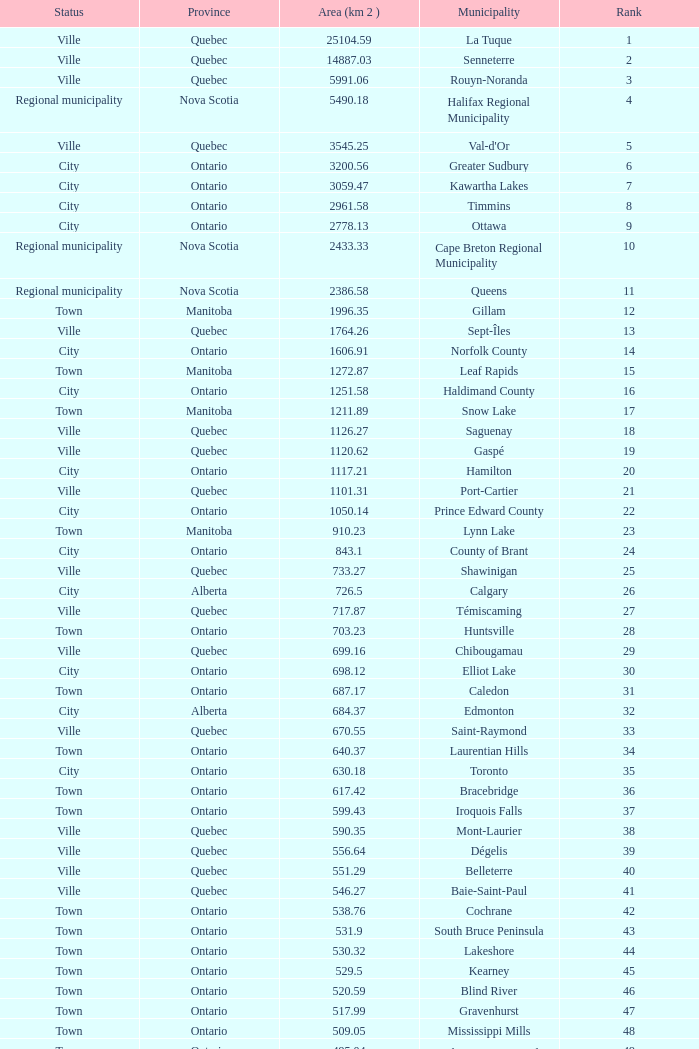What's the total of Rank that has an Area (KM 2) of 1050.14? 22.0. 